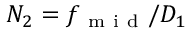Convert formula to latex. <formula><loc_0><loc_0><loc_500><loc_500>N _ { 2 } = f _ { m i d } / D _ { 1 }</formula> 